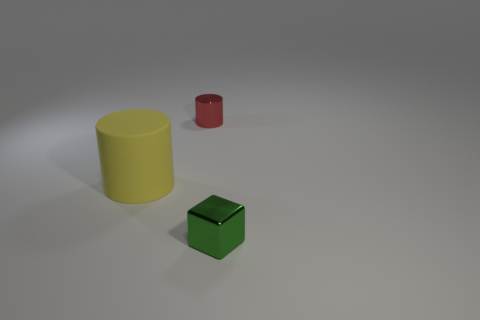There is a large yellow matte thing; is it the same shape as the tiny metal object behind the large object? The large yellow object appears to be a cylinder, which is indeed the same basic shape as the smaller red object located behind it. Both share a cylindrical form with circular tops and bottoms, but their sizes, colors, and materials are different. The large yellow one is matte and plastic in appearance, while the smaller one has a metallic sheen, indicative of perhaps being made of metal. 